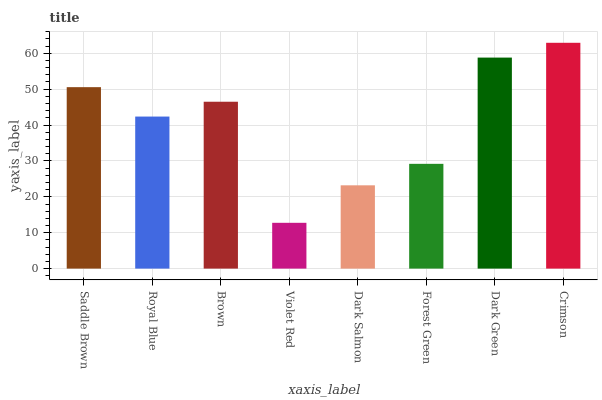Is Violet Red the minimum?
Answer yes or no. Yes. Is Crimson the maximum?
Answer yes or no. Yes. Is Royal Blue the minimum?
Answer yes or no. No. Is Royal Blue the maximum?
Answer yes or no. No. Is Saddle Brown greater than Royal Blue?
Answer yes or no. Yes. Is Royal Blue less than Saddle Brown?
Answer yes or no. Yes. Is Royal Blue greater than Saddle Brown?
Answer yes or no. No. Is Saddle Brown less than Royal Blue?
Answer yes or no. No. Is Brown the high median?
Answer yes or no. Yes. Is Royal Blue the low median?
Answer yes or no. Yes. Is Crimson the high median?
Answer yes or no. No. Is Crimson the low median?
Answer yes or no. No. 